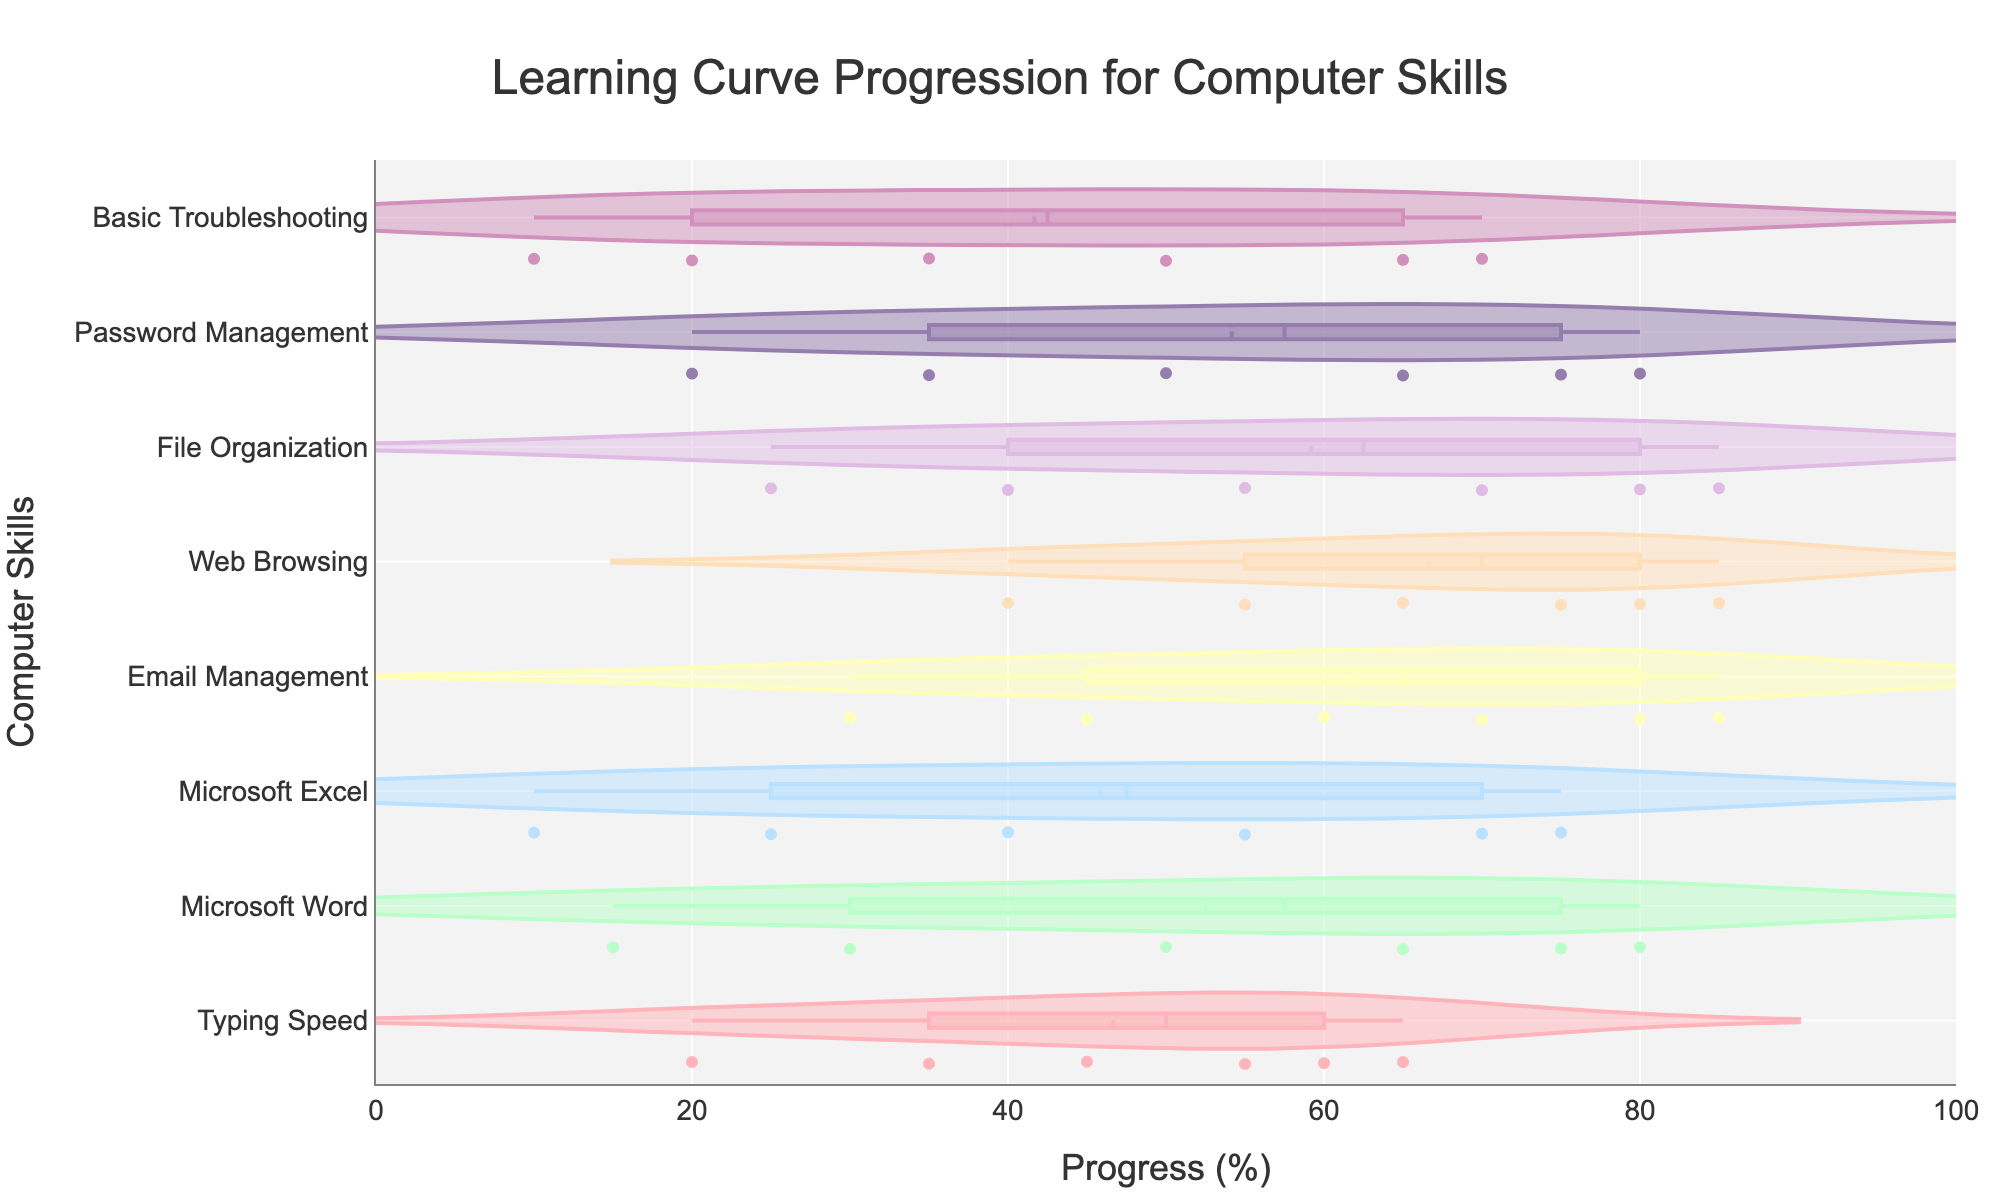What is the title of the figure? The title of the figure is prominently displayed at the top, centered, and it indicates what the figure represents.
Answer: Learning Curve Progression for Computer Skills What are the labels of the x-axis and y-axis? The x-axis and y-axis labels can be found below the x-axis and beside the y-axis respectively, providing clarity on what each axis measures. The x-axis measures progress as a percentage, and the y-axis lists different computer skills.
Answer: Progress (%) and Computer Skills Which skill shows the highest median progress in Week 6? The figure has box plots which show median lines. By comparing these lines, we can identify which one is the highest. The skill with the median line furthest to the right in Week 6 is the one with the highest median progress.
Answer: Email Management Which skills have identical median progress in Week 6? Identifying the identical median progresses involves finding box plots that have median lines (horizontal lines in the box) at the same position on the x-axis in Week 6.
Answer: Web Browsing and File Organization What is the interquartile range (IQR) for Microsoft Excel in Week 4? The interquartile range (IQR) is the difference between the first quartile (25th percentile) and the third quartile (75th percentile) of the data presented in the box plot. For Microsoft Excel in Week 4, identify these two points on the box plot.
Answer: 55-40 = 15 For which skill does the progress increase the most from Week 1 to Week 6? By comparing the box plots of each skill, find the one whose range starts lower in Week 1 and ends highest in Week 6. This skill has the largest increase.
Answer: Typing Speed Which skill has the widest range of progress values in Week 6? The range of progress values is the gap between the smallest (bottom whisker) and largest (top whisker) values in the box plot. Identify the longest whisker spread among skills in Week 6.
Answer: Basic Troubleshooting What's the average progress for Microsoft Excel from Week 1 to Week 6? To calculate the average progress for Microsoft Excel, sum the progress values from Week 1 to Week 6 and divide by the number of data points. Specifically, sum (10 + 25 + 40 + 55 + 70 + 75) and divide by 6.
Answer: (10 + 25 + 40 + 55 + 70 + 75) / 6 = 45.83 Which skill shows the least improvement from Week 1 to Week 6? Determine the difference in progress from Week 1 to Week 6 for all skills. The skill with the smallest difference shows the least improvement.
Answer: Basic Troubleshooting How can you visually identify the skills that have consistent progress throughout the weeks? Skills with consistent progress have box plots that are tightly clustered with small ranges and mean lines close to one another over weeks. Look for box plots with little dispersion across Weeks 1 to 6.
Answer: Answer may vary based on observation, typically skills like Web Browsing and File Organization 